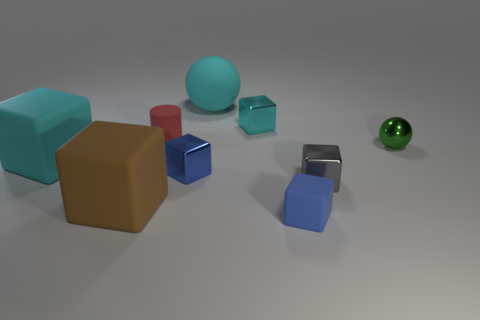Subtract all tiny gray blocks. How many blocks are left? 5 Subtract all gray cubes. How many cubes are left? 5 Subtract all purple blocks. Subtract all cyan cylinders. How many blocks are left? 6 Add 1 purple metallic cylinders. How many objects exist? 10 Subtract all balls. How many objects are left? 7 Add 7 big cyan rubber spheres. How many big cyan rubber spheres exist? 8 Subtract 1 cyan blocks. How many objects are left? 8 Subtract all small cubes. Subtract all green shiny spheres. How many objects are left? 4 Add 5 small green spheres. How many small green spheres are left? 6 